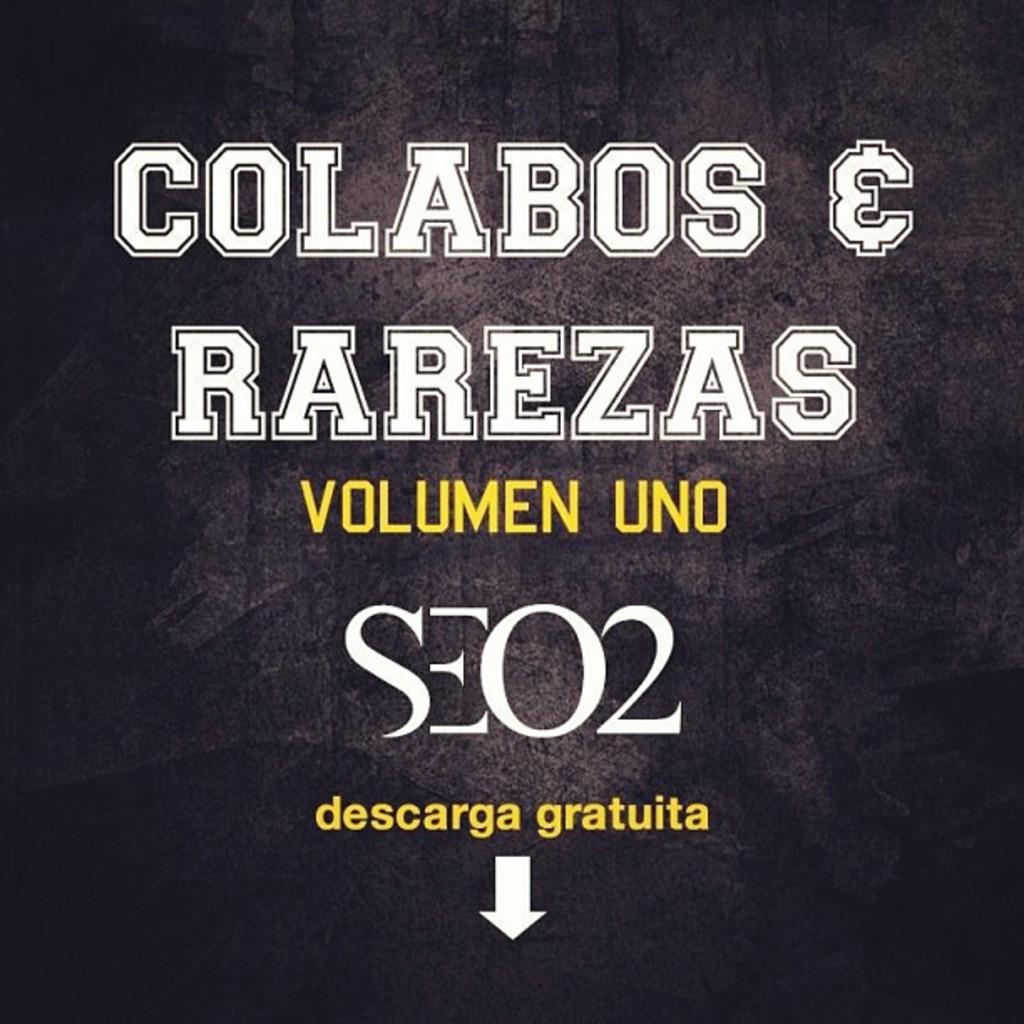Provide a one-sentence caption for the provided image. A cover of an album which states volume one with an arrow pointing down for a free download. 